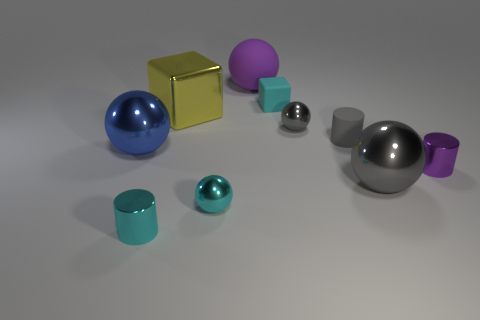Subtract all cyan spheres. How many spheres are left? 4 Subtract all big blue balls. How many balls are left? 4 Subtract all brown spheres. Subtract all brown cylinders. How many spheres are left? 5 Subtract all cylinders. How many objects are left? 7 Subtract 1 yellow cubes. How many objects are left? 9 Subtract all large blue metallic things. Subtract all green rubber balls. How many objects are left? 9 Add 3 big objects. How many big objects are left? 7 Add 6 small purple cylinders. How many small purple cylinders exist? 7 